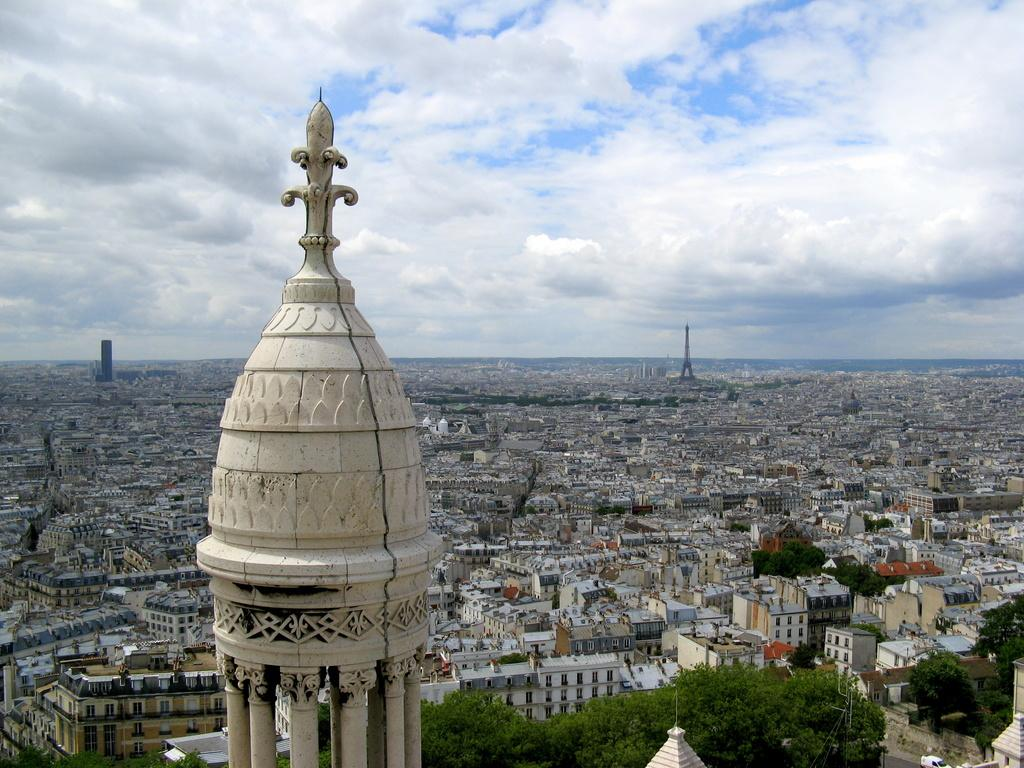What is the perspective of the image? The image is taken from a top view. What structures can be seen in the image? There are towers and buildings in the image. What type of vegetation is present in the image? There are trees in the image. What part of the natural environment is visible in the image? The sky is visible in the image. What can be observed in the sky? Clouds are present in the sky. What type of magic is being performed in the image? There is no magic or any indication of a magical performance in the image. Can you see any popcorn in the image? There is no popcorn present in the image. 